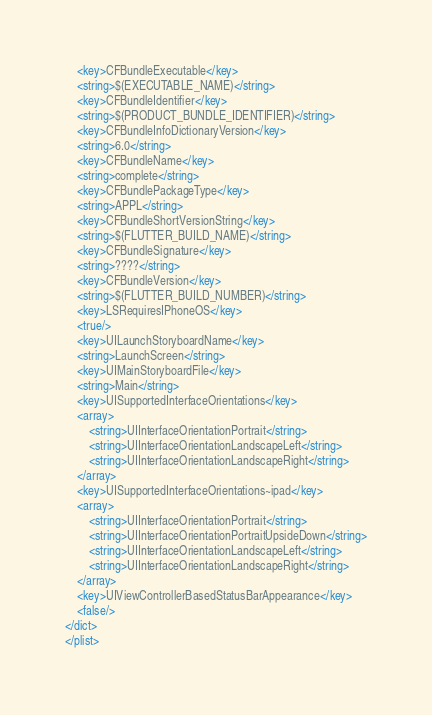Convert code to text. <code><loc_0><loc_0><loc_500><loc_500><_XML_>	<key>CFBundleExecutable</key>
	<string>$(EXECUTABLE_NAME)</string>
	<key>CFBundleIdentifier</key>
	<string>$(PRODUCT_BUNDLE_IDENTIFIER)</string>
	<key>CFBundleInfoDictionaryVersion</key>
	<string>6.0</string>
	<key>CFBundleName</key>
	<string>complete</string>
	<key>CFBundlePackageType</key>
	<string>APPL</string>
	<key>CFBundleShortVersionString</key>
	<string>$(FLUTTER_BUILD_NAME)</string>
	<key>CFBundleSignature</key>
	<string>????</string>
	<key>CFBundleVersion</key>
	<string>$(FLUTTER_BUILD_NUMBER)</string>
	<key>LSRequiresIPhoneOS</key>
	<true/>
	<key>UILaunchStoryboardName</key>
	<string>LaunchScreen</string>
	<key>UIMainStoryboardFile</key>
	<string>Main</string>
	<key>UISupportedInterfaceOrientations</key>
	<array>
		<string>UIInterfaceOrientationPortrait</string>
		<string>UIInterfaceOrientationLandscapeLeft</string>
		<string>UIInterfaceOrientationLandscapeRight</string>
	</array>
	<key>UISupportedInterfaceOrientations~ipad</key>
	<array>
		<string>UIInterfaceOrientationPortrait</string>
		<string>UIInterfaceOrientationPortraitUpsideDown</string>
		<string>UIInterfaceOrientationLandscapeLeft</string>
		<string>UIInterfaceOrientationLandscapeRight</string>
	</array>
	<key>UIViewControllerBasedStatusBarAppearance</key>
	<false/>
</dict>
</plist>
</code> 